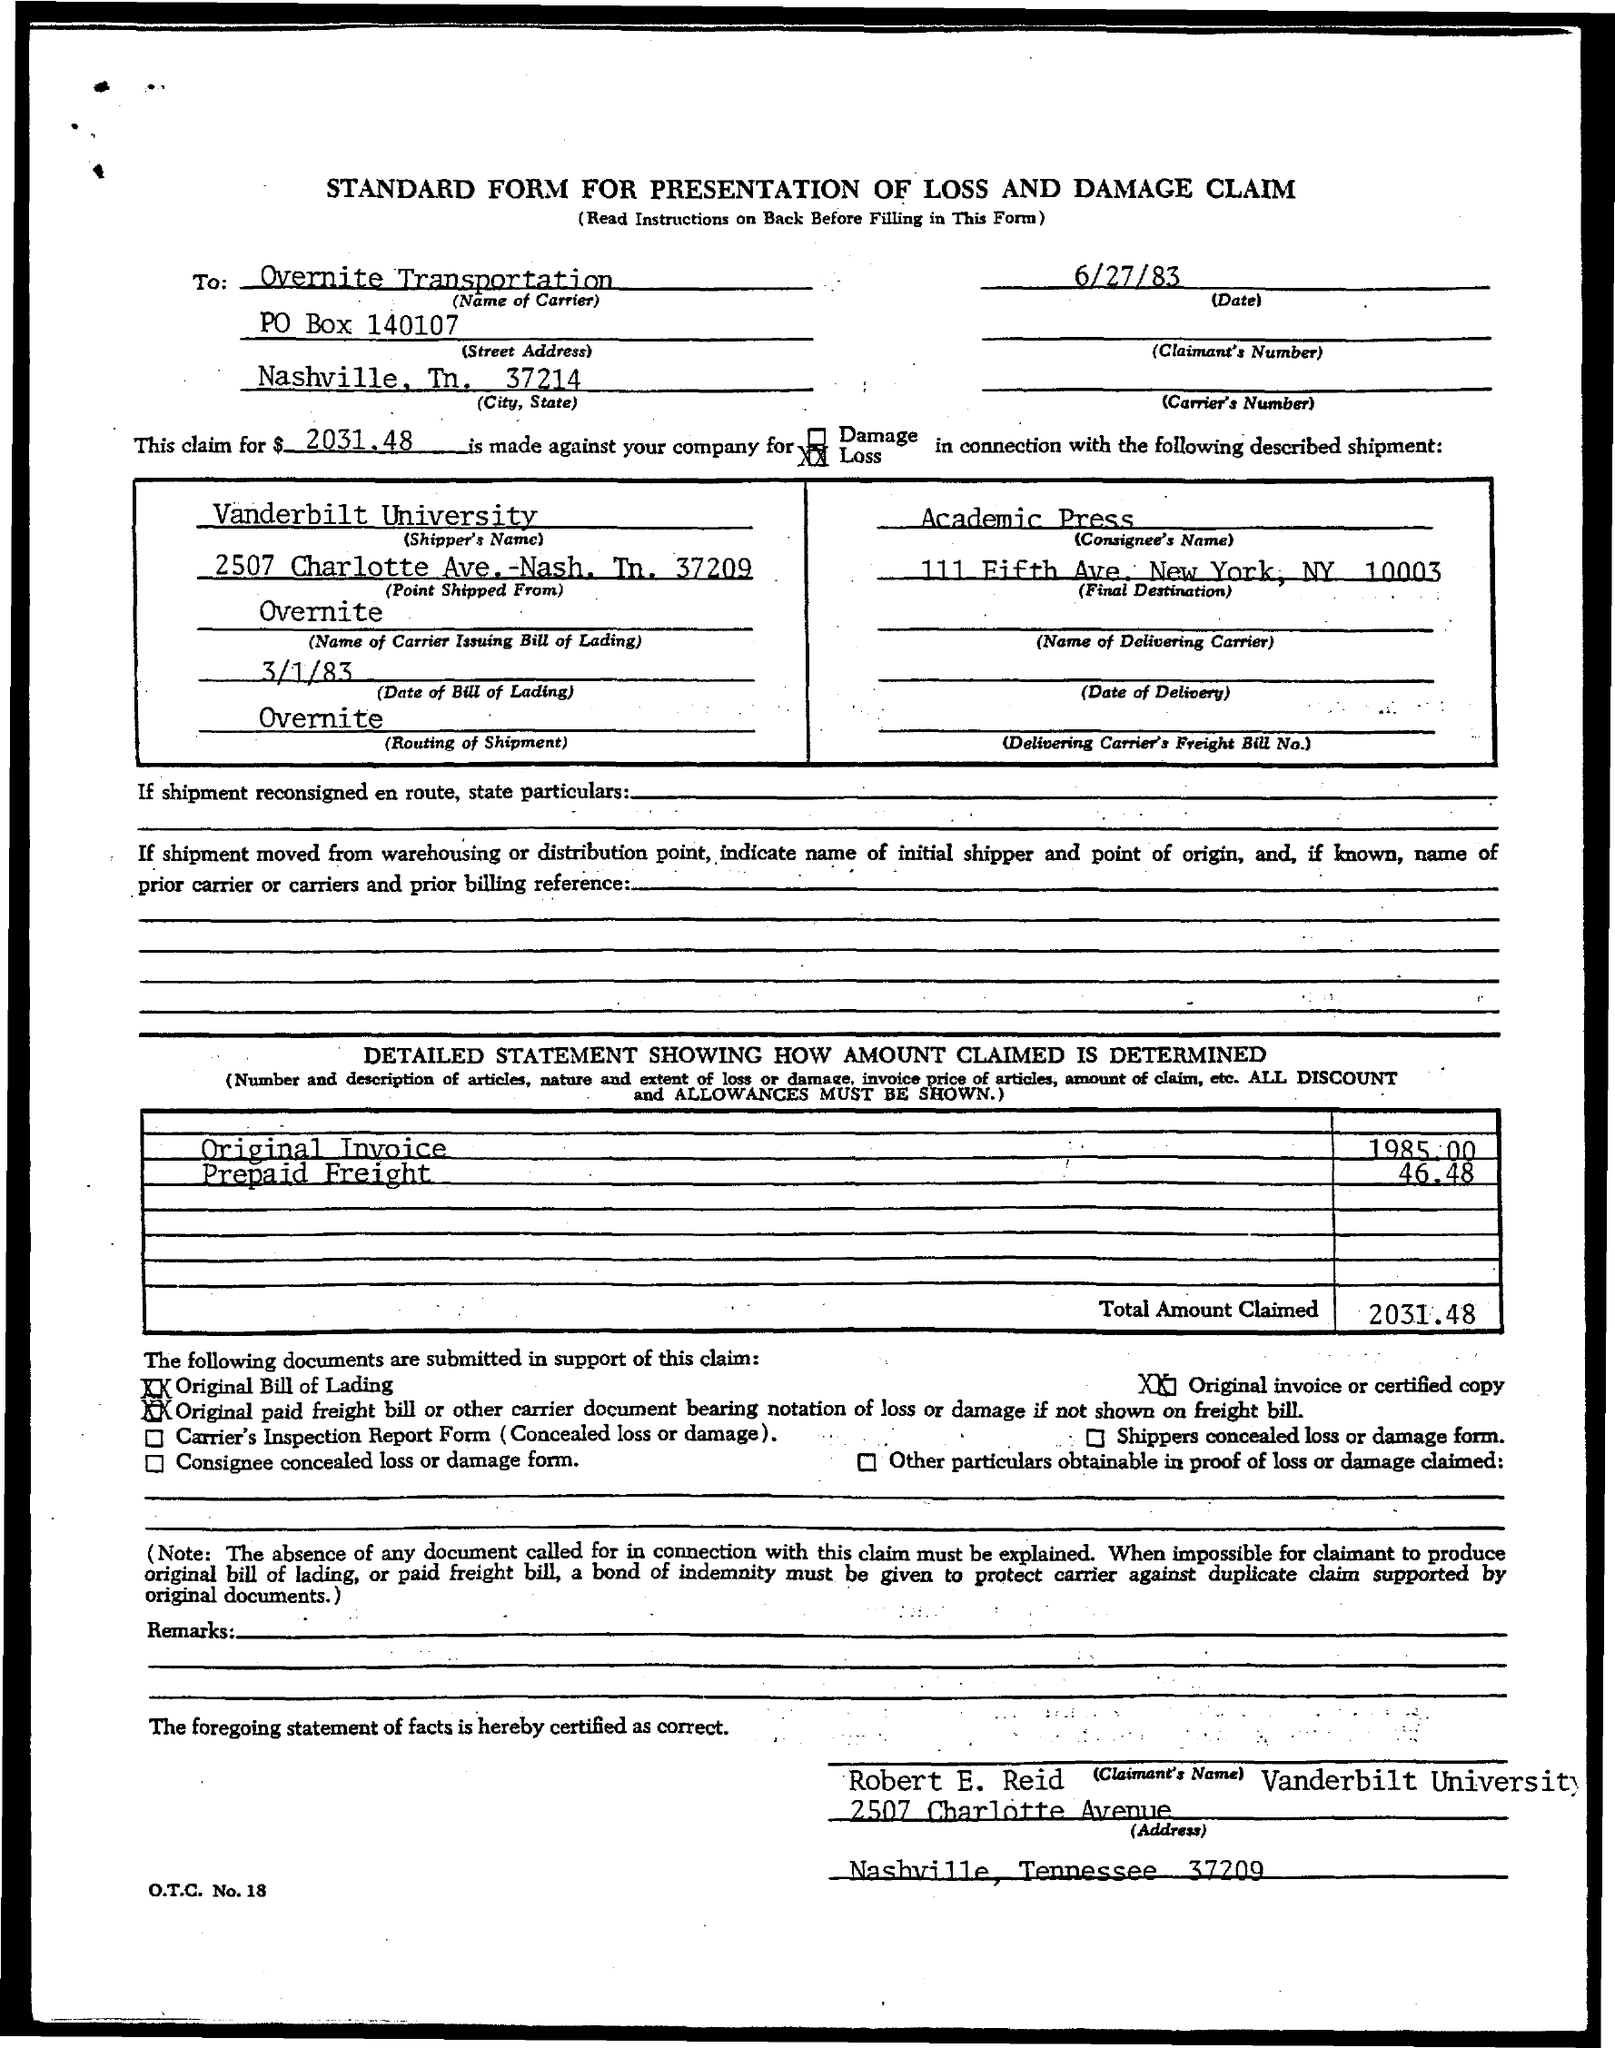What is the po box no. of overnite transportation ?
Provide a succinct answer. 140107. What is the claimed amount?
Your answer should be very brief. 2031.48. What is the name of the consignee ?
Your answer should be compact. Academic Press. What is the address of academic press?
Make the answer very short. 111 Fifth Ave., New York, N.Y. 10003. What is shipper's name?
Offer a very short reply. Vanderbilt University. What is the routing of shipment?
Your answer should be compact. Overnite. What is the name of carrier issuing bill of lading?
Make the answer very short. Overnite. Where is the point shipped from?
Make the answer very short. 2507 Charlotte Ave. -Nash. Tn. 37209. 